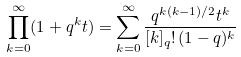<formula> <loc_0><loc_0><loc_500><loc_500>\prod _ { k = 0 } ^ { \infty } ( 1 + q ^ { k } t ) = \sum _ { k = 0 } ^ { \infty } { \frac { q ^ { k ( k - 1 ) / 2 } t ^ { k } } { [ k ] _ { q } ! \, ( 1 - q ) ^ { k } } }</formula> 